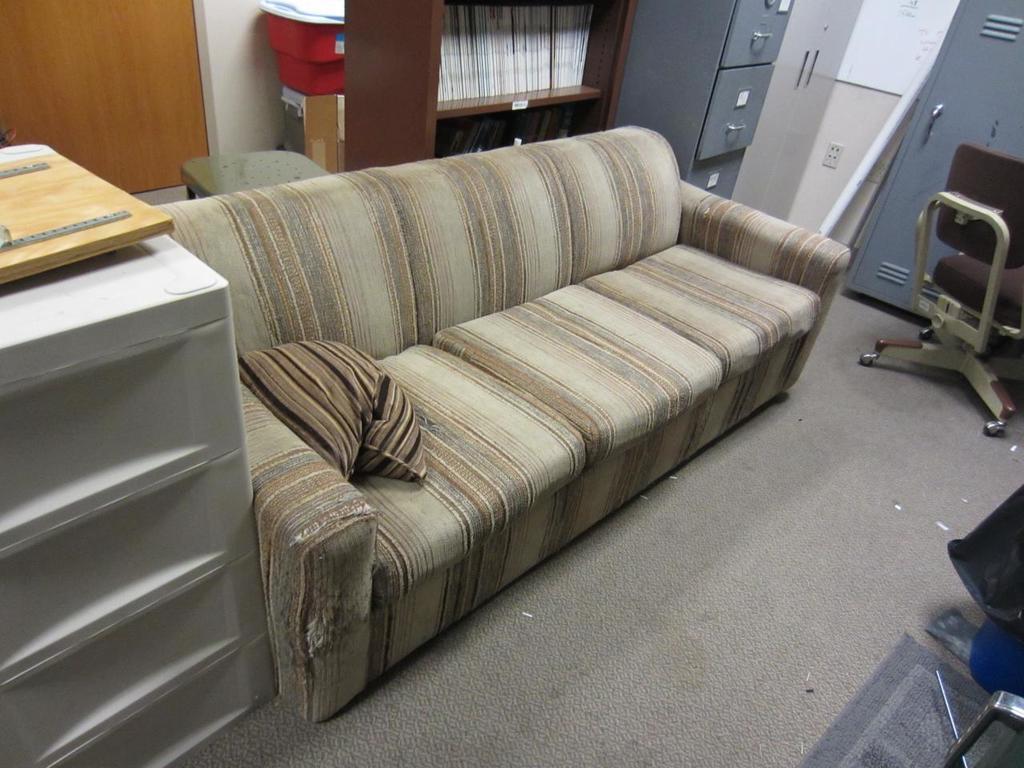Please provide a concise description of this image. this picture shows a sofa bed and we see a bookshelf and cupboards on the side and we see a chair 